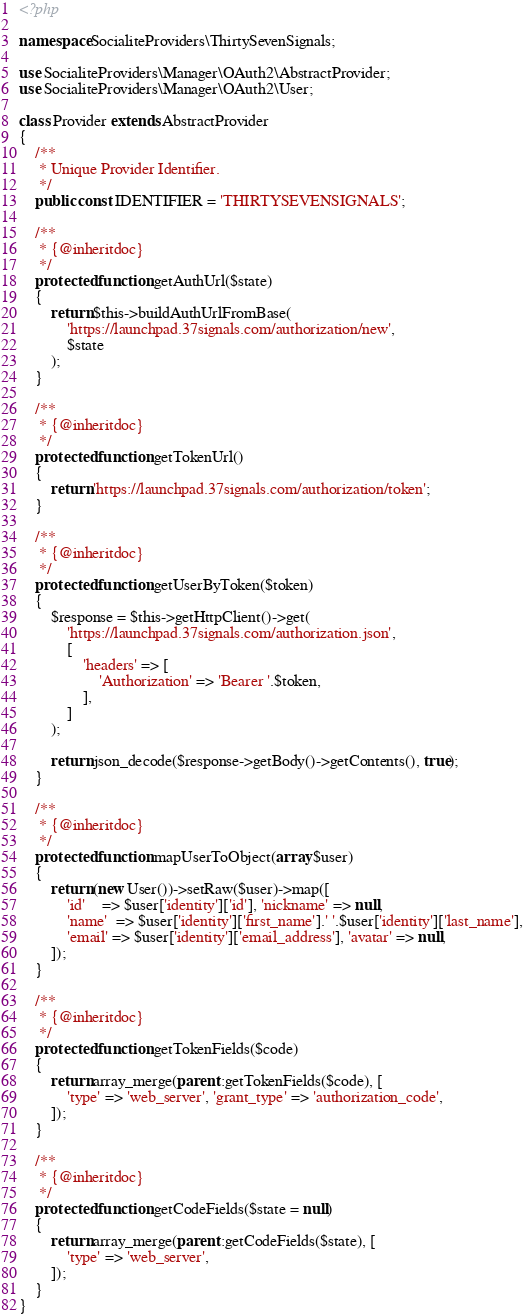Convert code to text. <code><loc_0><loc_0><loc_500><loc_500><_PHP_><?php

namespace SocialiteProviders\ThirtySevenSignals;

use SocialiteProviders\Manager\OAuth2\AbstractProvider;
use SocialiteProviders\Manager\OAuth2\User;

class Provider extends AbstractProvider
{
    /**
     * Unique Provider Identifier.
     */
    public const IDENTIFIER = 'THIRTYSEVENSIGNALS';

    /**
     * {@inheritdoc}
     */
    protected function getAuthUrl($state)
    {
        return $this->buildAuthUrlFromBase(
            'https://launchpad.37signals.com/authorization/new',
            $state
        );
    }

    /**
     * {@inheritdoc}
     */
    protected function getTokenUrl()
    {
        return 'https://launchpad.37signals.com/authorization/token';
    }

    /**
     * {@inheritdoc}
     */
    protected function getUserByToken($token)
    {
        $response = $this->getHttpClient()->get(
            'https://launchpad.37signals.com/authorization.json',
            [
                'headers' => [
                    'Authorization' => 'Bearer '.$token,
                ],
            ]
        );

        return json_decode($response->getBody()->getContents(), true);
    }

    /**
     * {@inheritdoc}
     */
    protected function mapUserToObject(array $user)
    {
        return (new User())->setRaw($user)->map([
            'id'    => $user['identity']['id'], 'nickname' => null,
            'name'  => $user['identity']['first_name'].' '.$user['identity']['last_name'],
            'email' => $user['identity']['email_address'], 'avatar' => null,
        ]);
    }

    /**
     * {@inheritdoc}
     */
    protected function getTokenFields($code)
    {
        return array_merge(parent::getTokenFields($code), [
            'type' => 'web_server', 'grant_type' => 'authorization_code',
        ]);
    }

    /**
     * {@inheritdoc}
     */
    protected function getCodeFields($state = null)
    {
        return array_merge(parent::getCodeFields($state), [
            'type' => 'web_server',
        ]);
    }
}
</code> 